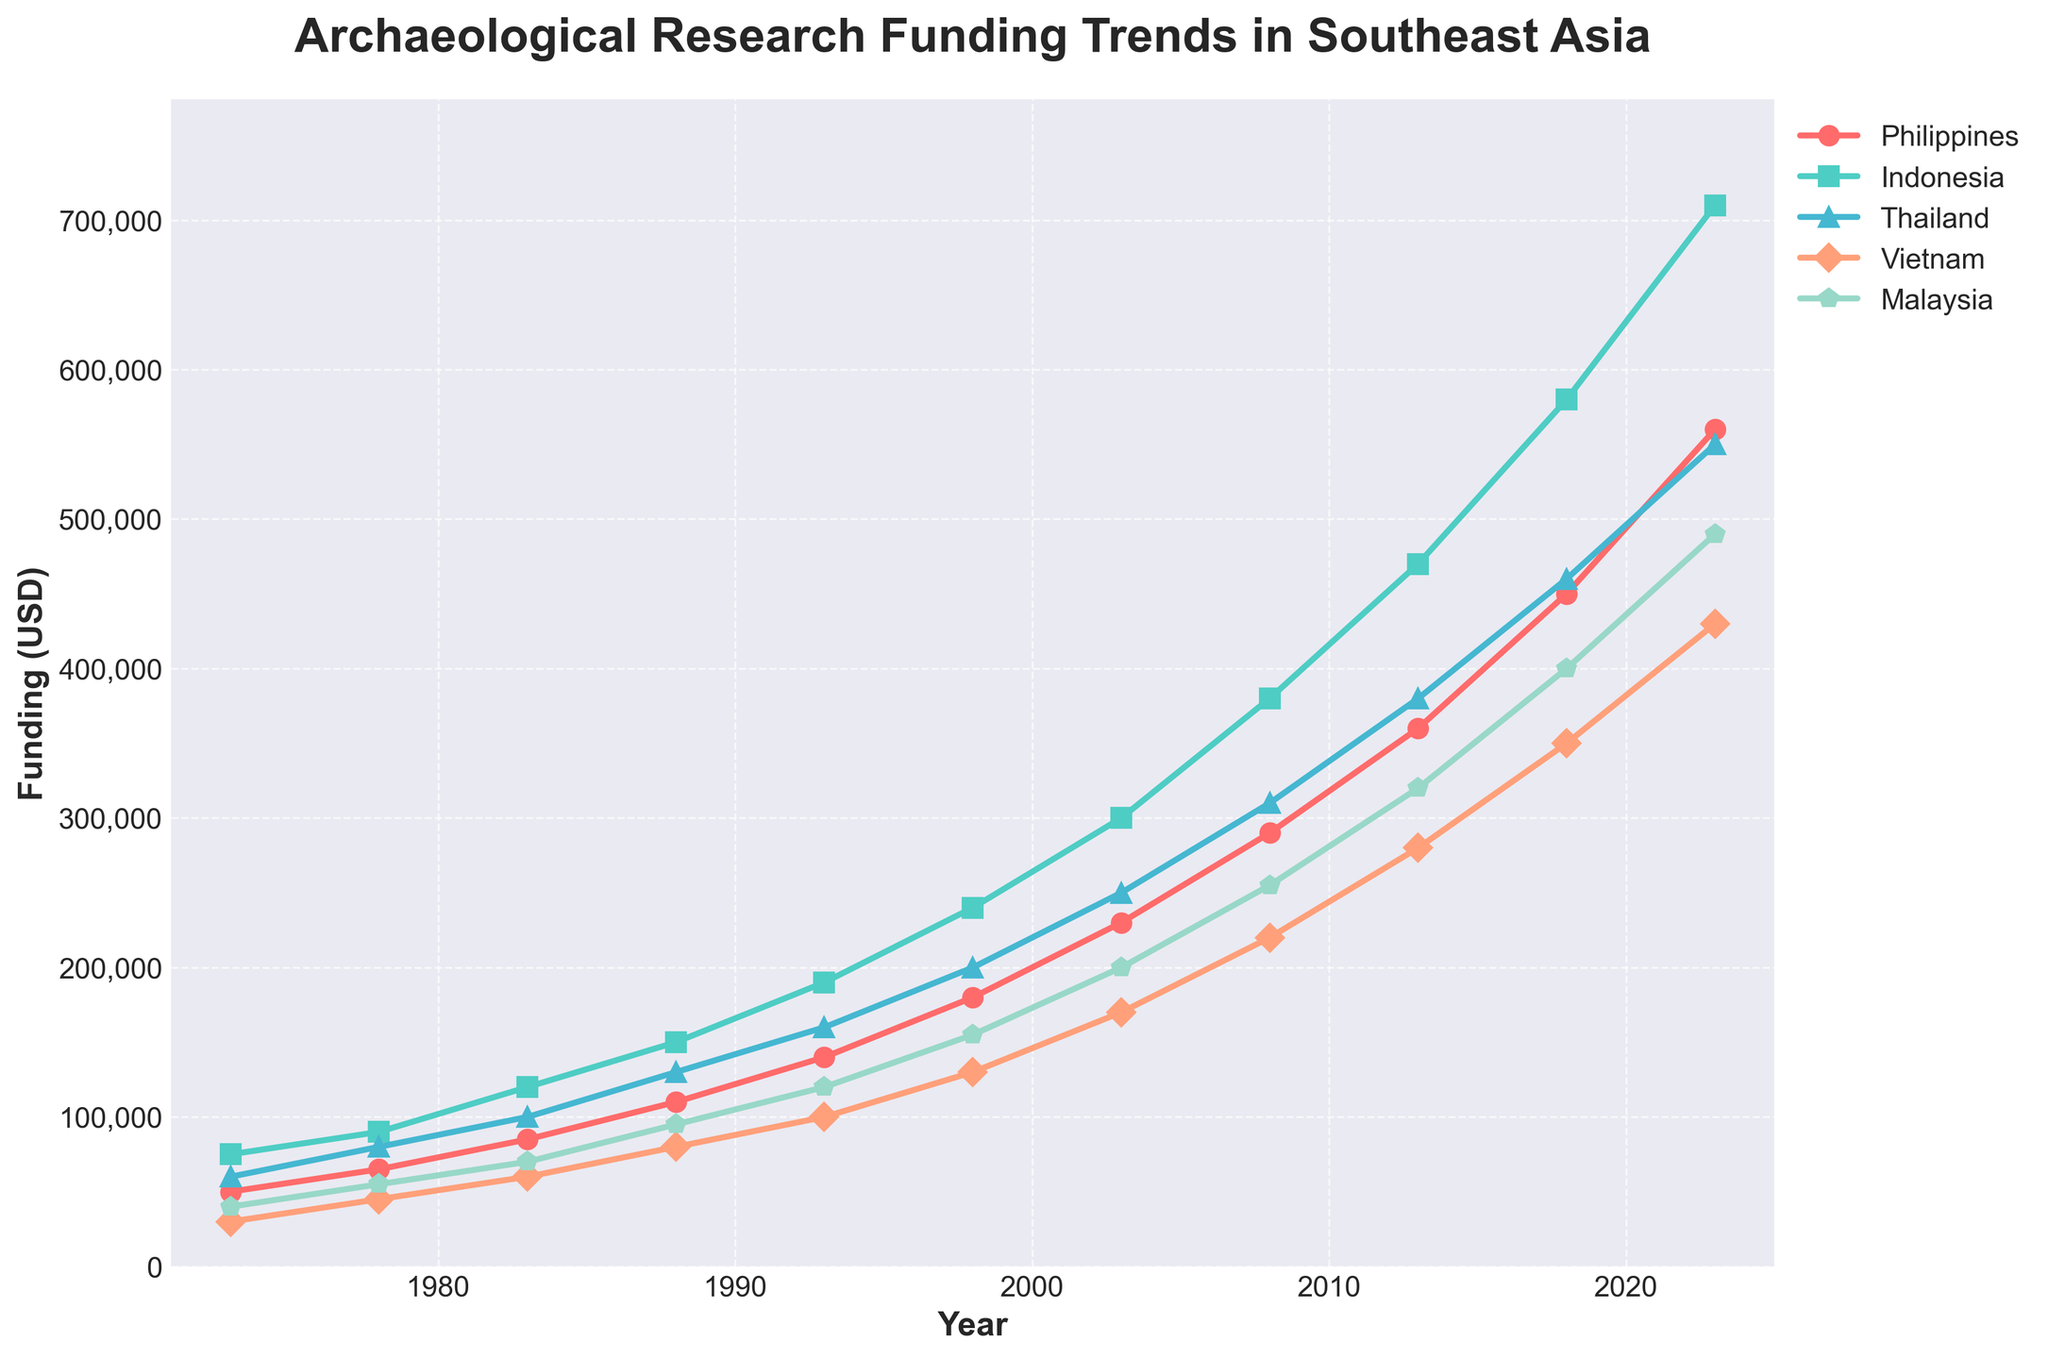Which country experienced the highest increase in funding from 1973 to 2023? By examining the chart, we can see that Indonesia had the highest increase in funding. In 1973, Indonesia's funding was $75,000, while it reached $710,000 in 2023. Subtract the initial amount from the final amount: $710,000 - $75,000 = $635,000.
Answer: Indonesia Between 2013 and 2018, which country saw the greatest increase in funding, and what was the amount? By comparing the funding levels for each country between 2013 and 2018 on the chart, we can see that the Philippines saw the greatest increase, with funding going from $360,000 in 2013 to $450,000 in 2018. Calculate the difference: $450,000 - $360,000 = $90,000.
Answer: Philippines, $90,000 In which year did Thailand's funding surpass Vietnam's funding? Observing the chart, we can see that in 2003, Thailand's funding increased to $250,000, while Vietnam's funding was $170,000. Hence, 2003 is the year when Thailand's funding first surpassed Vietnam's funding.
Answer: 2003 How much did Malaysia's funding increase from 1998 to 2023? By reading the chart, Malaysia's funding was $155,000 in 1998 and increased to $490,000 in 2023. Calculate the increase by subtracting the 1998 value from the 2023 value: $490,000 - $155,000 = $335,000.
Answer: $335,000 By how much did the Philippines' funding increase in comparison with Thailand’s funding increase from 1973 to 2023? The Philippines' funding went from $50,000 in 1973 to $560,000 in 2023, an increase of $510,000. Thailand's funding increased from $60,000 to $550,000, an increase of $490,000. To find the difference, subtract Thailand's increase from the Philippines' increase: $510,000 - $490,000 = $20,000.
Answer: $20,000 Which year marked the most substantial single-year increase in funding for Vietnam? Reviewing the chart shows that between 2013 and 2018, Vietnam's funding jumped from $280,000 to $350,000. Calculate the difference: $350,000 - $280,000 = $70,000. This is the largest single-year increase.
Answer: Between 2013 and 2018, $70,000 What was the average funding for Malaysia from 1973 to 2023? To calculate the average, sum up Malaysia's funding over the specified years and divide by the number of years. Summing: $400,000 + $55,000 + $700,000 + $95,000 + $120,000 + $155,000 + $200,000 + $255,000 + $320,000 + $400,000 + $490,000 = $2,850,000. Average: $2,850,000 / 11 = $259,091 (approx).
Answer: $259,091 